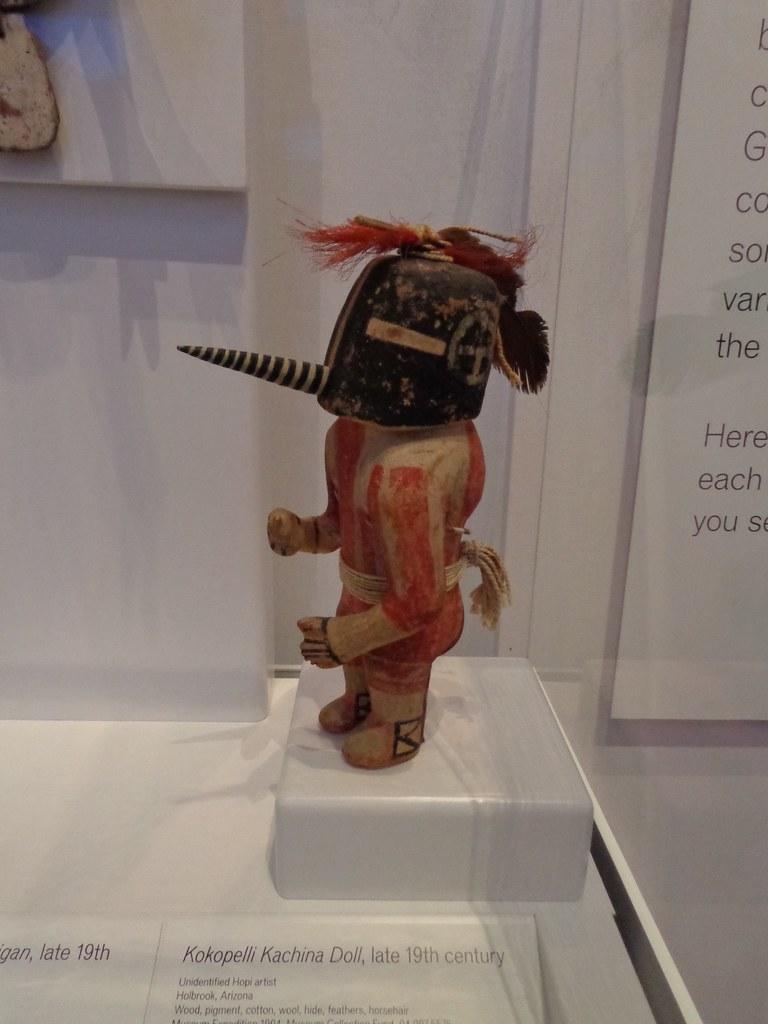Could you give a brief overview of what you see in this image? In this image, we can see an object on the white colored surface. We can see the wall with an object and a board with some text. We can also see some text at the bottom. 